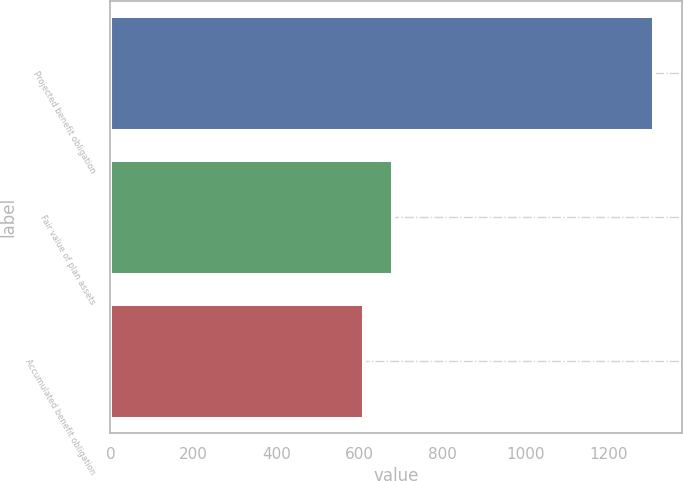<chart> <loc_0><loc_0><loc_500><loc_500><bar_chart><fcel>Projected benefit obligation<fcel>Fair value of plan assets<fcel>Accumulated benefit obligation<nl><fcel>1310<fcel>680.9<fcel>611<nl></chart> 